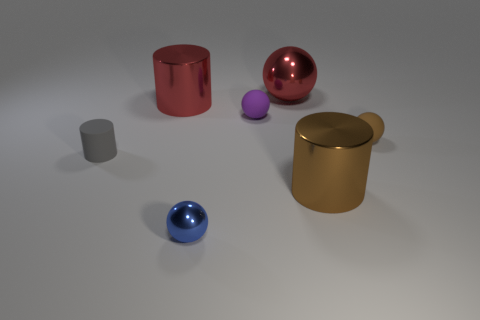What is the arrangement of objects in terms of their colors? The objects are arranged with a mix of vivid and muted colors. Starting from the front, there's a bright blue sphere, followed by muted grey cylinders of different sizes, a vibrant purple sphere, a glossy red sphere, and finally a large yellow cylindrical container with a lid. 